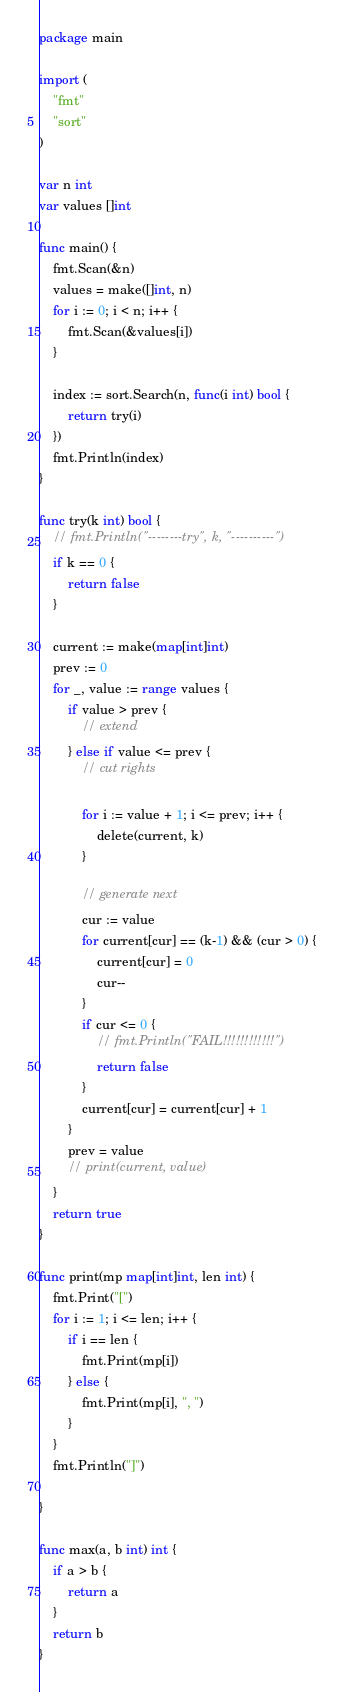<code> <loc_0><loc_0><loc_500><loc_500><_Go_>package main

import (
	"fmt"
	"sort"
)

var n int
var values []int

func main() {
	fmt.Scan(&n)
	values = make([]int, n)
	for i := 0; i < n; i++ {
		fmt.Scan(&values[i])
	}

	index := sort.Search(n, func(i int) bool {
		return try(i)
	})
	fmt.Println(index)
}

func try(k int) bool {
	// fmt.Println("--------try", k, "----------")
	if k == 0 {
		return false
	}

	current := make(map[int]int)
	prev := 0
	for _, value := range values {
		if value > prev {
			// extend
		} else if value <= prev {
			// cut rights

			for i := value + 1; i <= prev; i++ {
				delete(current, k)
			}

			// generate next
			cur := value
			for current[cur] == (k-1) && (cur > 0) {
				current[cur] = 0
				cur--
			}
			if cur <= 0 {
				// fmt.Println("FAIL!!!!!!!!!!!!")
				return false
			}
			current[cur] = current[cur] + 1
		}
		prev = value
		// print(current, value)
	}
	return true
}

func print(mp map[int]int, len int) {
	fmt.Print("[")
	for i := 1; i <= len; i++ {
		if i == len {
			fmt.Print(mp[i])
		} else {
			fmt.Print(mp[i], ", ")
		}
	}
	fmt.Println("]")

}

func max(a, b int) int {
	if a > b {
		return a
	}
	return b
}
</code> 